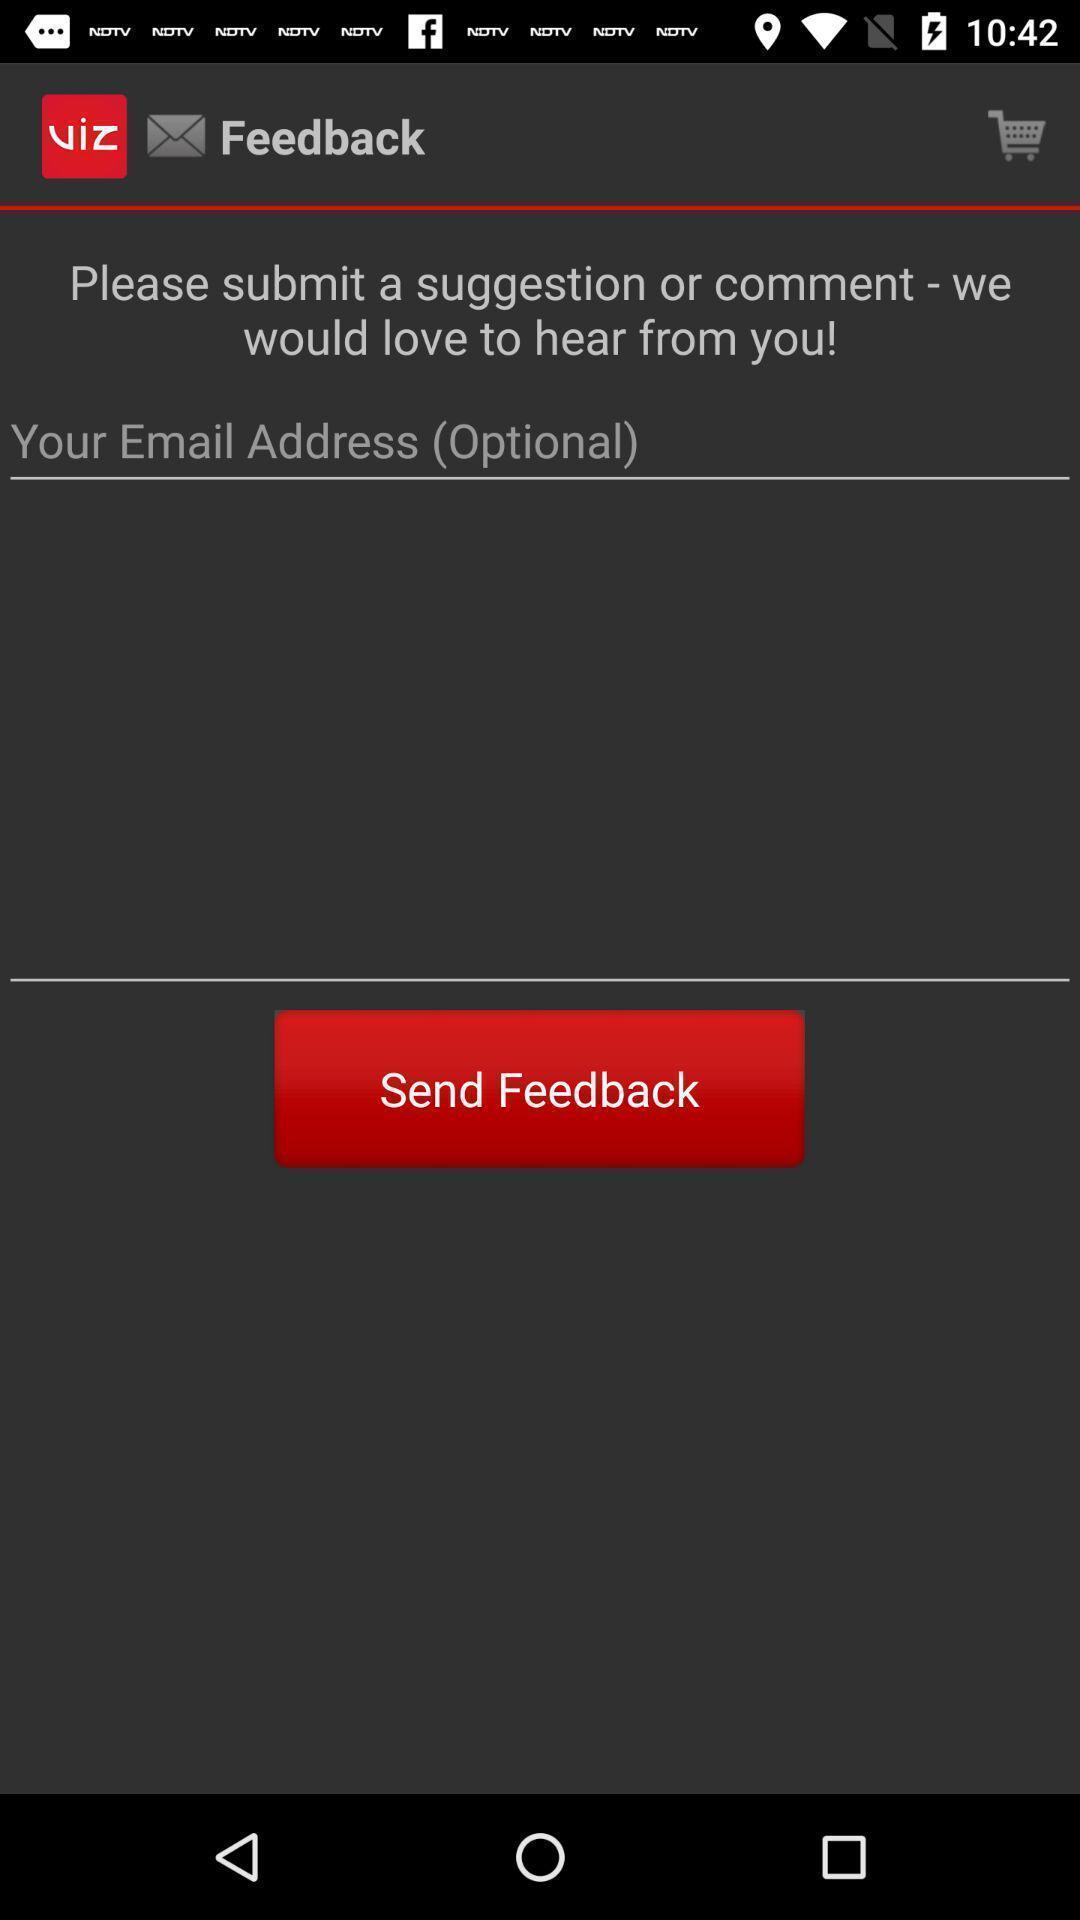Explain what's happening in this screen capture. Suggestions to send a feedback. 